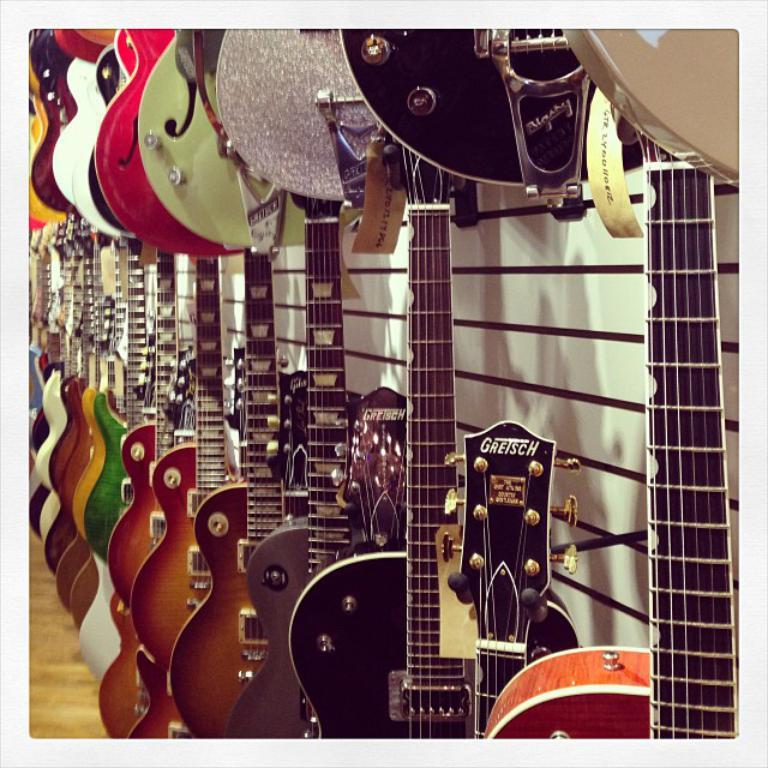What type of musical instruments are placed on the wall in the image? There are guitars placed on a wall in the image. How are the guitars arranged on the wall? The guitars are arranged in rows on the wall. What can be observed about the appearance of the guitars? The guitars are of different colors and have patterns on them. What type of gold pipe can be seen connecting the guitars in the image? There is no gold pipe connecting the guitars in the image; they are simply arranged in rows on the wall. 